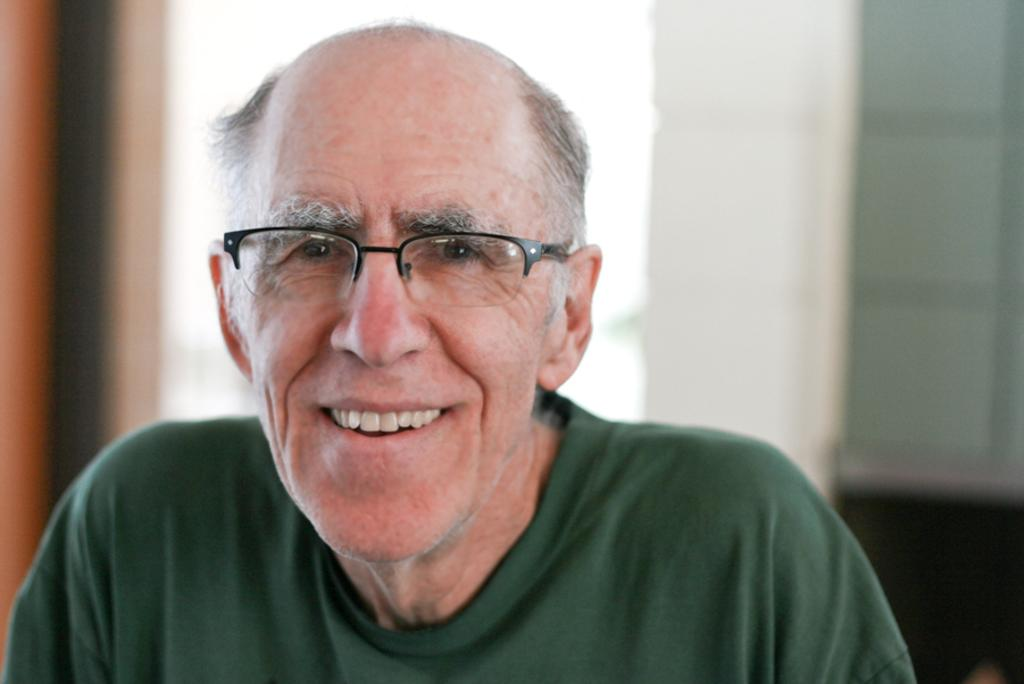Who is the main subject in the picture? There is an old man in the picture. What is the old man doing in the picture? The old man is smiling. What accessory is the old man wearing in the picture? The old man is wearing spectacles. What type of prose is the old man reading in the picture? There is no prose visible in the picture, as the old man is not holding or reading any text. Can you see a pig in the picture? No, there is no pig present in the picture. 